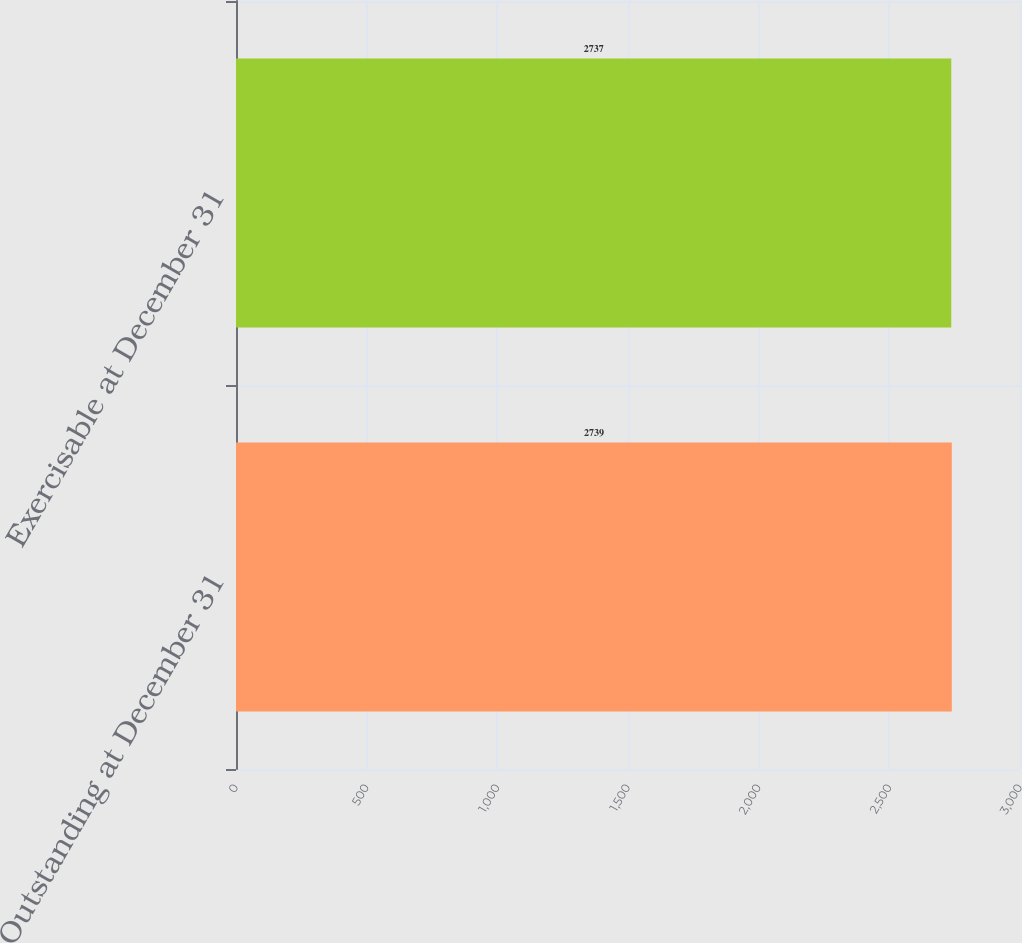Convert chart. <chart><loc_0><loc_0><loc_500><loc_500><bar_chart><fcel>Outstanding at December 31<fcel>Exercisable at December 31<nl><fcel>2739<fcel>2737<nl></chart> 